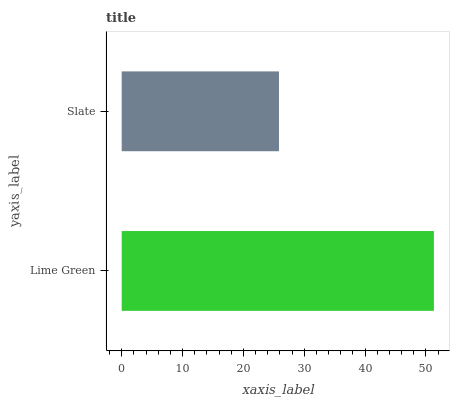Is Slate the minimum?
Answer yes or no. Yes. Is Lime Green the maximum?
Answer yes or no. Yes. Is Slate the maximum?
Answer yes or no. No. Is Lime Green greater than Slate?
Answer yes or no. Yes. Is Slate less than Lime Green?
Answer yes or no. Yes. Is Slate greater than Lime Green?
Answer yes or no. No. Is Lime Green less than Slate?
Answer yes or no. No. Is Lime Green the high median?
Answer yes or no. Yes. Is Slate the low median?
Answer yes or no. Yes. Is Slate the high median?
Answer yes or no. No. Is Lime Green the low median?
Answer yes or no. No. 